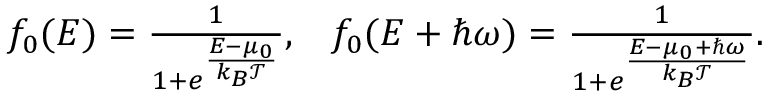<formula> <loc_0><loc_0><loc_500><loc_500>\begin{array} { r } { { f _ { 0 } ( E ) = \frac { 1 } { 1 + e ^ { \frac { E - \mu _ { 0 } } { k _ { B } \mathcal { T } } } } , } { \quad f _ { 0 } ( E + \hbar { \omega } ) = \frac { 1 } { 1 + e ^ { \frac { E - \mu _ { 0 } + \hbar { \omega } } { k _ { B } \mathcal { T } } } } } . } \end{array}</formula> 